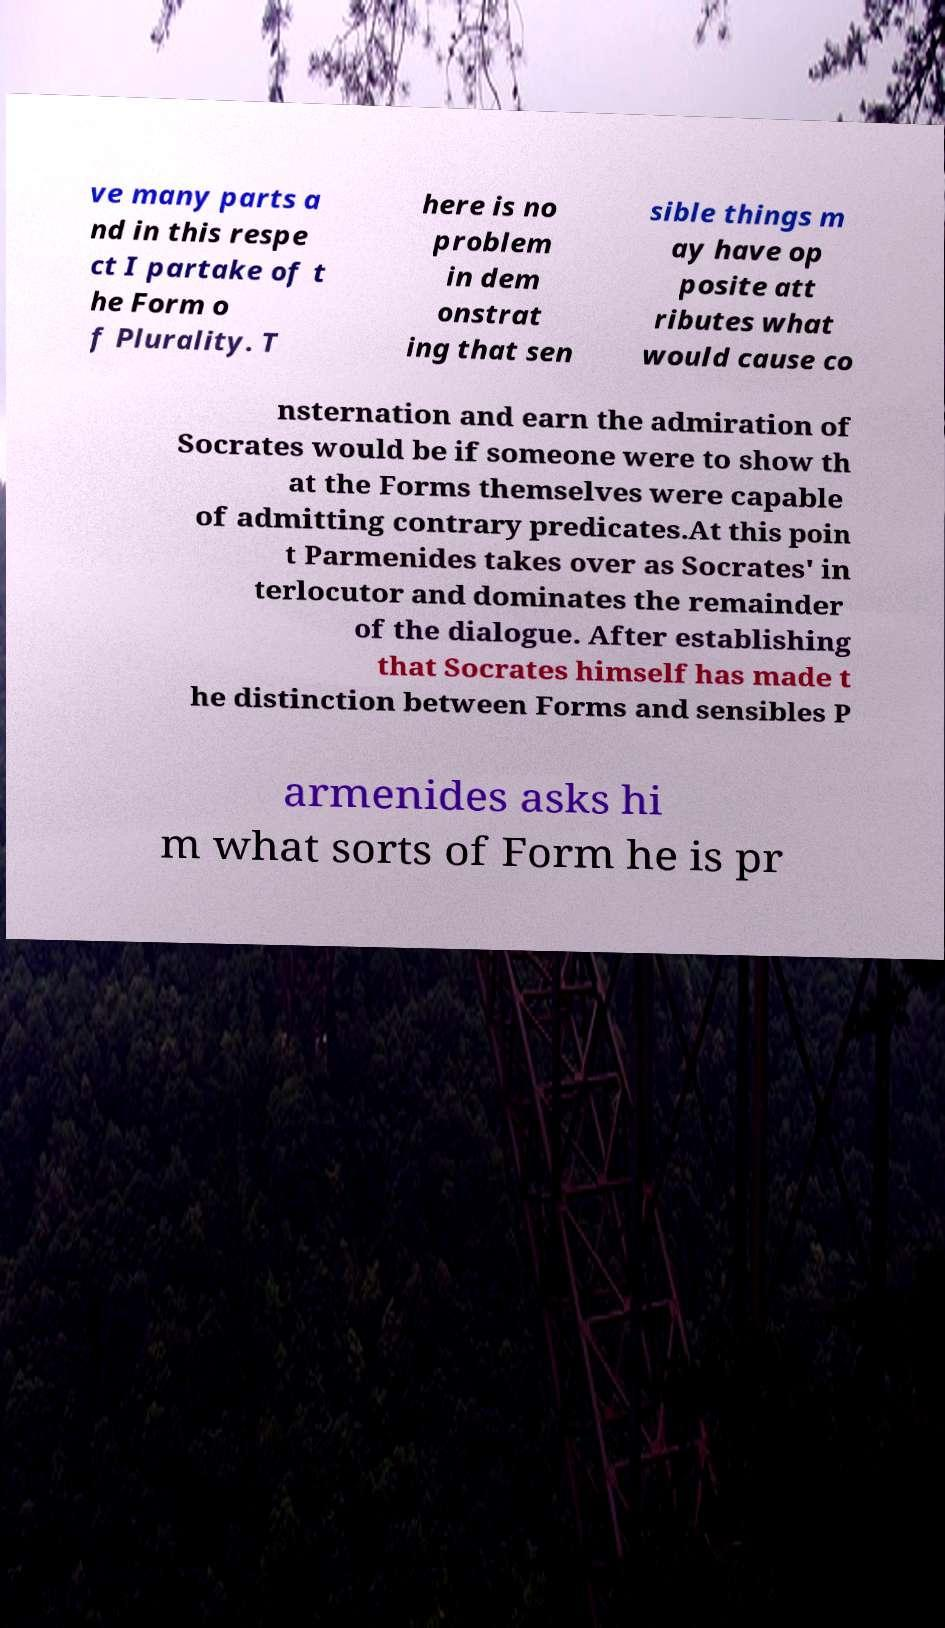I need the written content from this picture converted into text. Can you do that? ve many parts a nd in this respe ct I partake of t he Form o f Plurality. T here is no problem in dem onstrat ing that sen sible things m ay have op posite att ributes what would cause co nsternation and earn the admiration of Socrates would be if someone were to show th at the Forms themselves were capable of admitting contrary predicates.At this poin t Parmenides takes over as Socrates' in terlocutor and dominates the remainder of the dialogue. After establishing that Socrates himself has made t he distinction between Forms and sensibles P armenides asks hi m what sorts of Form he is pr 